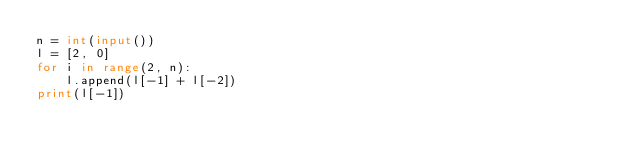<code> <loc_0><loc_0><loc_500><loc_500><_Python_>n = int(input())
l = [2, 0]
for i in range(2, n):
    l.append(l[-1] + l[-2])
print(l[-1])
</code> 